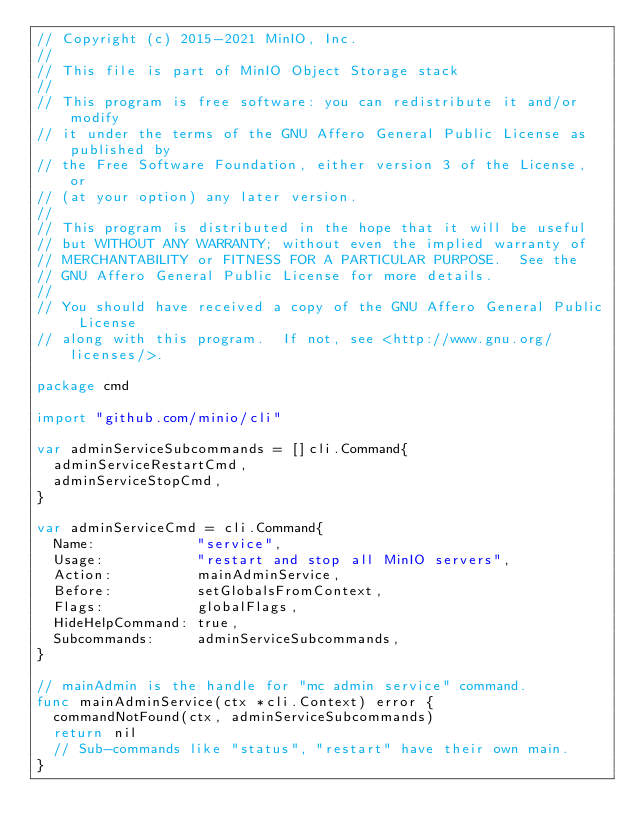<code> <loc_0><loc_0><loc_500><loc_500><_Go_>// Copyright (c) 2015-2021 MinIO, Inc.
//
// This file is part of MinIO Object Storage stack
//
// This program is free software: you can redistribute it and/or modify
// it under the terms of the GNU Affero General Public License as published by
// the Free Software Foundation, either version 3 of the License, or
// (at your option) any later version.
//
// This program is distributed in the hope that it will be useful
// but WITHOUT ANY WARRANTY; without even the implied warranty of
// MERCHANTABILITY or FITNESS FOR A PARTICULAR PURPOSE.  See the
// GNU Affero General Public License for more details.
//
// You should have received a copy of the GNU Affero General Public License
// along with this program.  If not, see <http://www.gnu.org/licenses/>.

package cmd

import "github.com/minio/cli"

var adminServiceSubcommands = []cli.Command{
	adminServiceRestartCmd,
	adminServiceStopCmd,
}

var adminServiceCmd = cli.Command{
	Name:            "service",
	Usage:           "restart and stop all MinIO servers",
	Action:          mainAdminService,
	Before:          setGlobalsFromContext,
	Flags:           globalFlags,
	HideHelpCommand: true,
	Subcommands:     adminServiceSubcommands,
}

// mainAdmin is the handle for "mc admin service" command.
func mainAdminService(ctx *cli.Context) error {
	commandNotFound(ctx, adminServiceSubcommands)
	return nil
	// Sub-commands like "status", "restart" have their own main.
}
</code> 